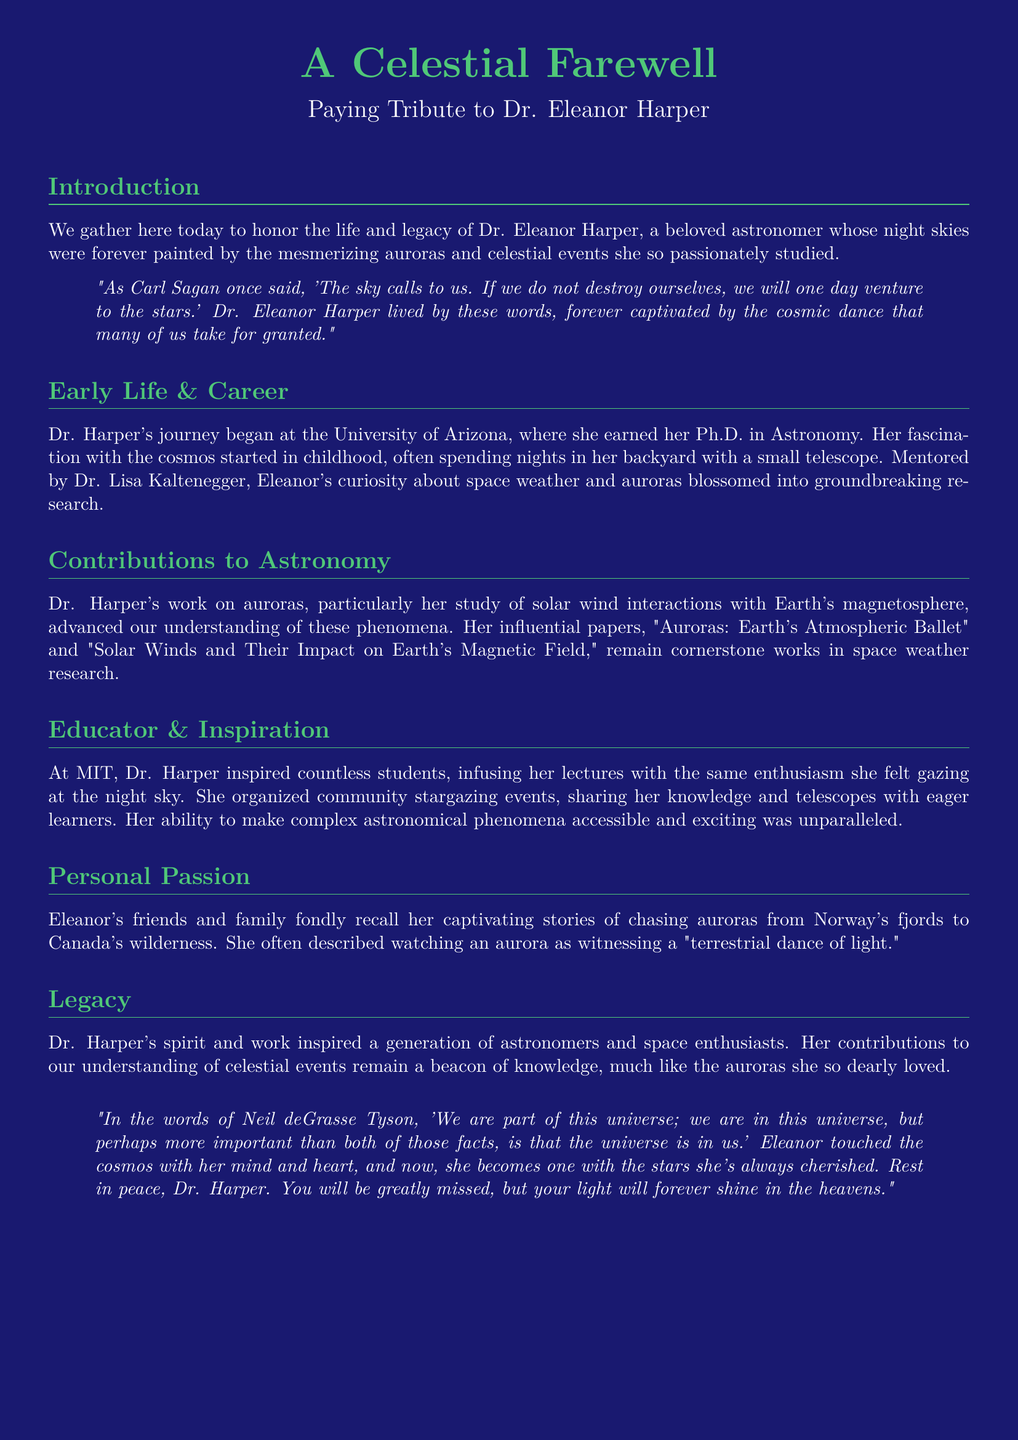What is the name of the astronomer being honored? The document explicitly mentions Dr. Eleanor Harper as the individual being commemorated.
Answer: Dr. Eleanor Harper Where did Dr. Harper earn her Ph.D.? The document states that Dr. Harper began her journey at the University of Arizona, where she earned her Ph.D.
Answer: University of Arizona What were the titles of two influential papers by Dr. Harper? The text lists "Auroras: Earth's Atmospheric Ballet" and "Solar Winds and Their Impact on Earth's Magnetic Field" as her influential papers.
Answer: Auroras: Earth's Atmospheric Ballet, Solar Winds and Their Impact on Earth's Magnetic Field Which university did Dr. Harper work at as an educator? The document mentions that Dr. Harper inspired students at MIT, indicating her role as an educator there.
Answer: MIT What personal experience did Eleanor often share regarding auroras? The document notes that Eleanor’s friends and family recall her stories of chasing auroras in various locations.
Answer: Chasing auroras in Norway's fjords and Canada's wilderness What legacy did Dr. Harper leave behind? The text states that her spirit and work continue to inspire a generation of astronomers and space enthusiasts.
Answer: Inspired a generation of astronomers and space enthusiasts 